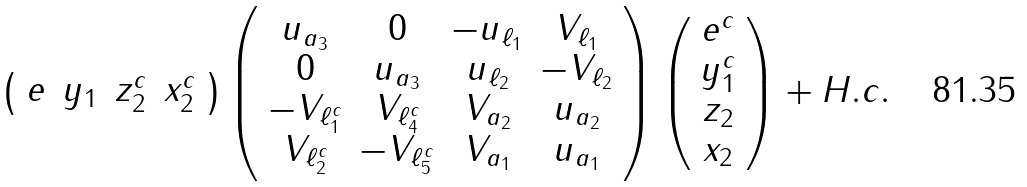Convert formula to latex. <formula><loc_0><loc_0><loc_500><loc_500>\left ( \begin{array} { c c c c } e & y _ { 1 } & z _ { 2 } ^ { c } & x _ { 2 } ^ { c } \end{array} \right ) \left ( \begin{array} { c c c c } u _ { a _ { 3 } } & 0 & - u _ { \ell _ { 1 } } & V _ { \ell _ { 1 } } \\ 0 & u _ { a _ { 3 } } & u _ { \ell _ { 2 } } & - V _ { \ell _ { 2 } } \\ - V _ { \ell ^ { c } _ { 1 } } & V _ { \ell ^ { c } _ { 4 } } & V _ { a _ { 2 } } & u _ { a _ { 2 } } \\ V _ { \ell ^ { c } _ { 2 } } & - V _ { \ell ^ { c } _ { 5 } } & V _ { a _ { 1 } } & u _ { a _ { 1 } } \end{array} \right ) \left ( \begin{array} { c } e ^ { c } \\ y _ { 1 } ^ { c } \\ z _ { 2 } \\ x _ { 2 } \end{array} \right ) + H . c .</formula> 